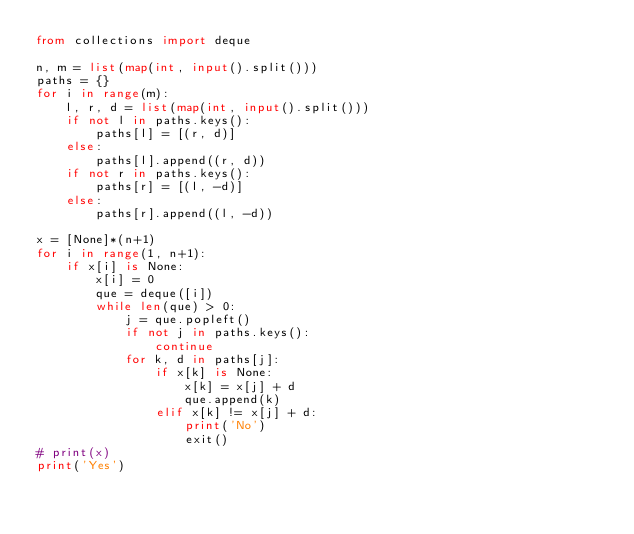<code> <loc_0><loc_0><loc_500><loc_500><_Python_>from collections import deque

n, m = list(map(int, input().split()))
paths = {}
for i in range(m):
    l, r, d = list(map(int, input().split()))
    if not l in paths.keys():
        paths[l] = [(r, d)]
    else:
        paths[l].append((r, d))
    if not r in paths.keys():
        paths[r] = [(l, -d)]
    else:
        paths[r].append((l, -d))
      
x = [None]*(n+1)
for i in range(1, n+1):
    if x[i] is None:
        x[i] = 0
        que = deque([i])
        while len(que) > 0:
            j = que.popleft()
            if not j in paths.keys():
                continue
            for k, d in paths[j]:
                if x[k] is None:
                    x[k] = x[j] + d
                    que.append(k)
                elif x[k] != x[j] + d:
                    print('No')
                    exit()
# print(x)
print('Yes')</code> 